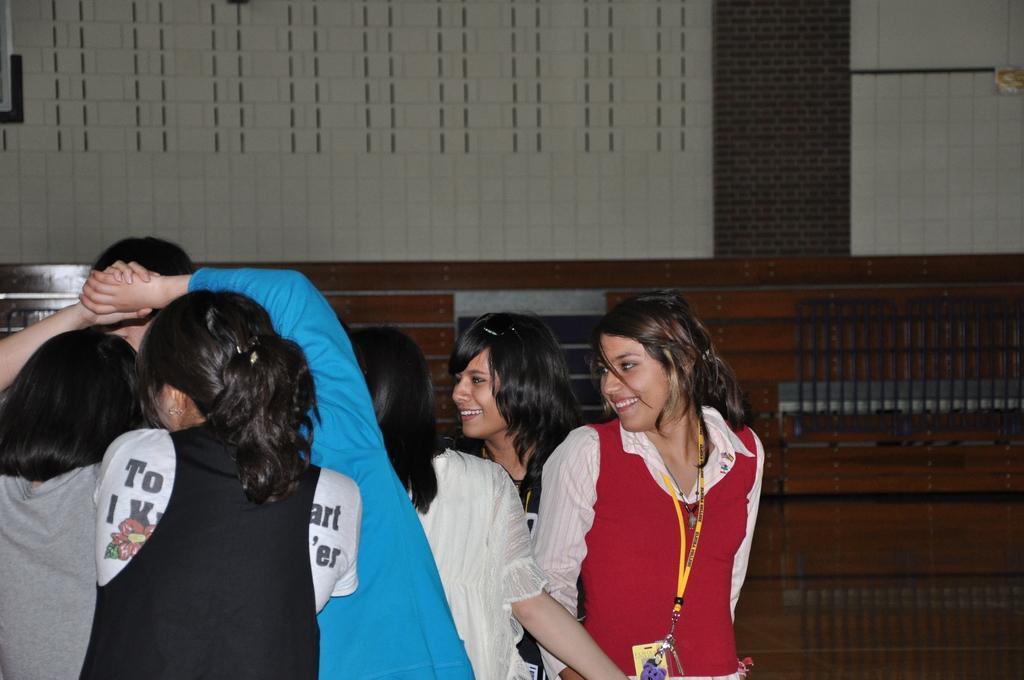Could you give a brief overview of what you see in this image? In this image we can see people at the bottom of the image. In the background of the image there is a wall. 